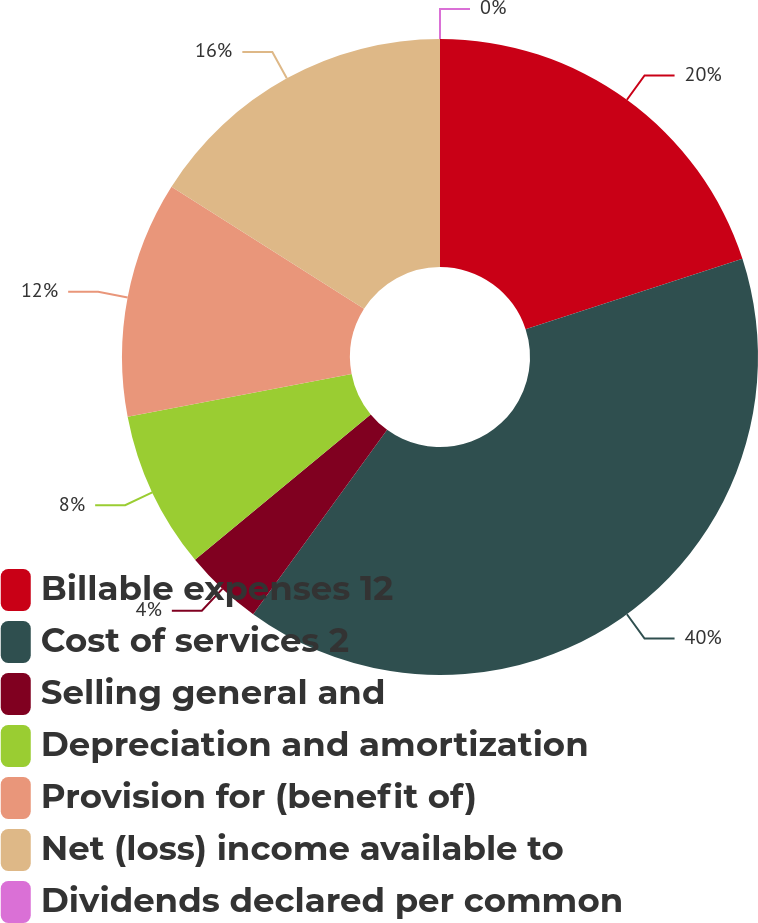<chart> <loc_0><loc_0><loc_500><loc_500><pie_chart><fcel>Billable expenses 12<fcel>Cost of services 2<fcel>Selling general and<fcel>Depreciation and amortization<fcel>Provision for (benefit of)<fcel>Net (loss) income available to<fcel>Dividends declared per common<nl><fcel>20.0%<fcel>39.99%<fcel>4.0%<fcel>8.0%<fcel>12.0%<fcel>16.0%<fcel>0.0%<nl></chart> 